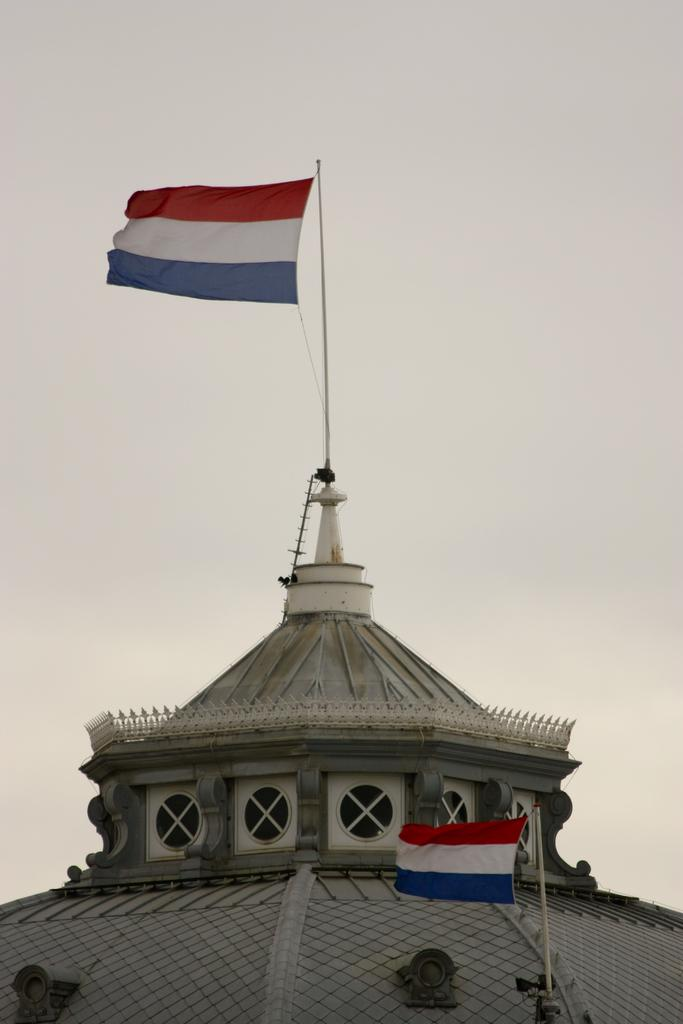What is located in the foreground of the image? There are two flags in the foreground of the image. Where are the flags positioned? The flags are on a dome. What can be seen in the background of the image? The sky is visible in the background of the image. What type of stew is being cooked in the image? There is no stew present in the image; it features two flags on a dome with the sky visible in the background. 